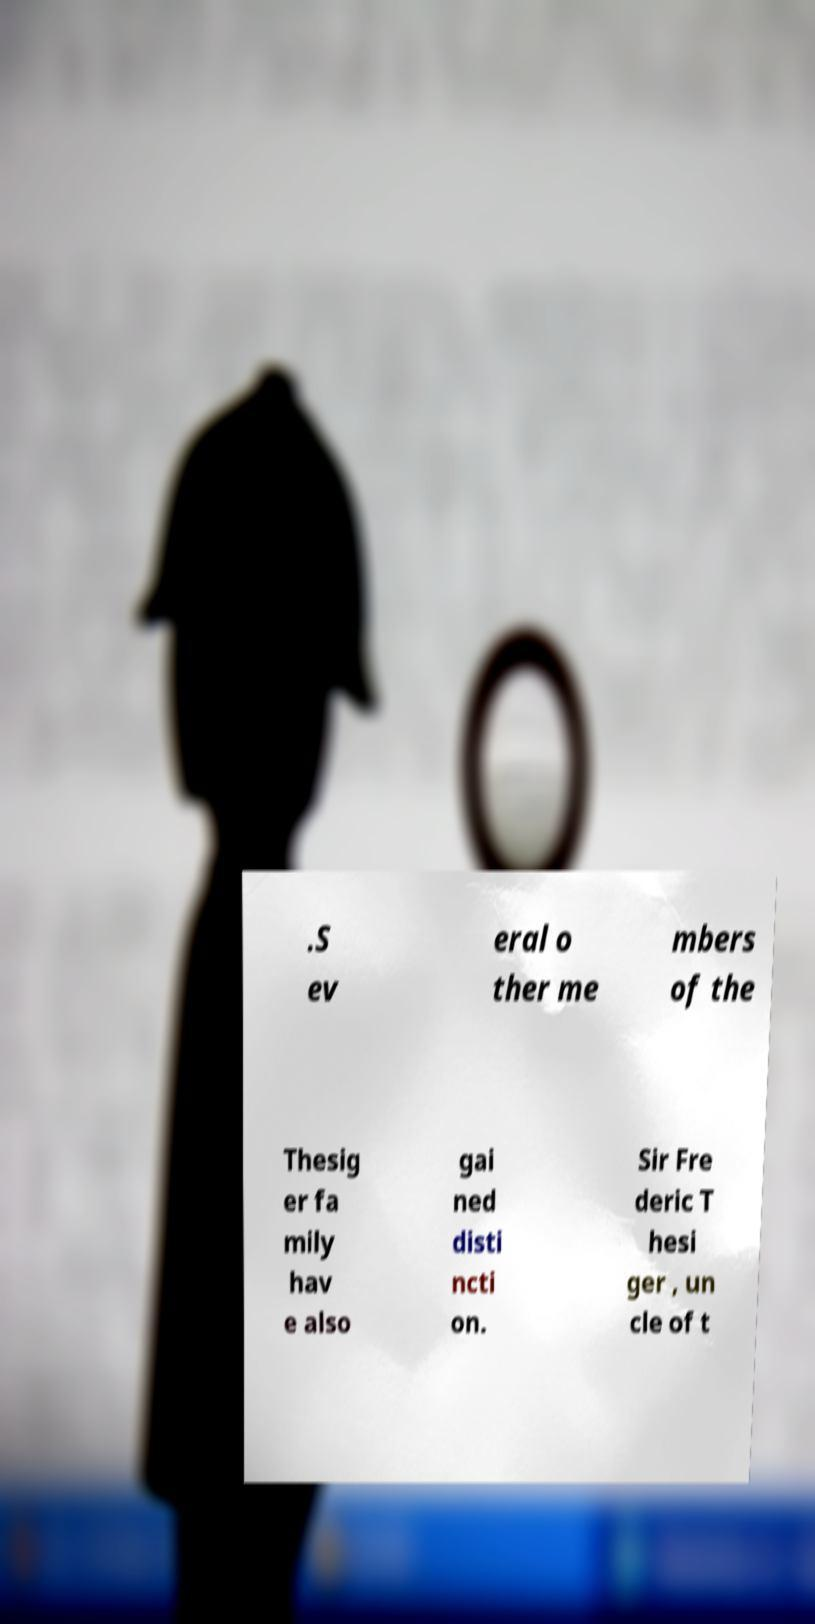Can you read and provide the text displayed in the image?This photo seems to have some interesting text. Can you extract and type it out for me? .S ev eral o ther me mbers of the Thesig er fa mily hav e also gai ned disti ncti on. Sir Fre deric T hesi ger , un cle of t 